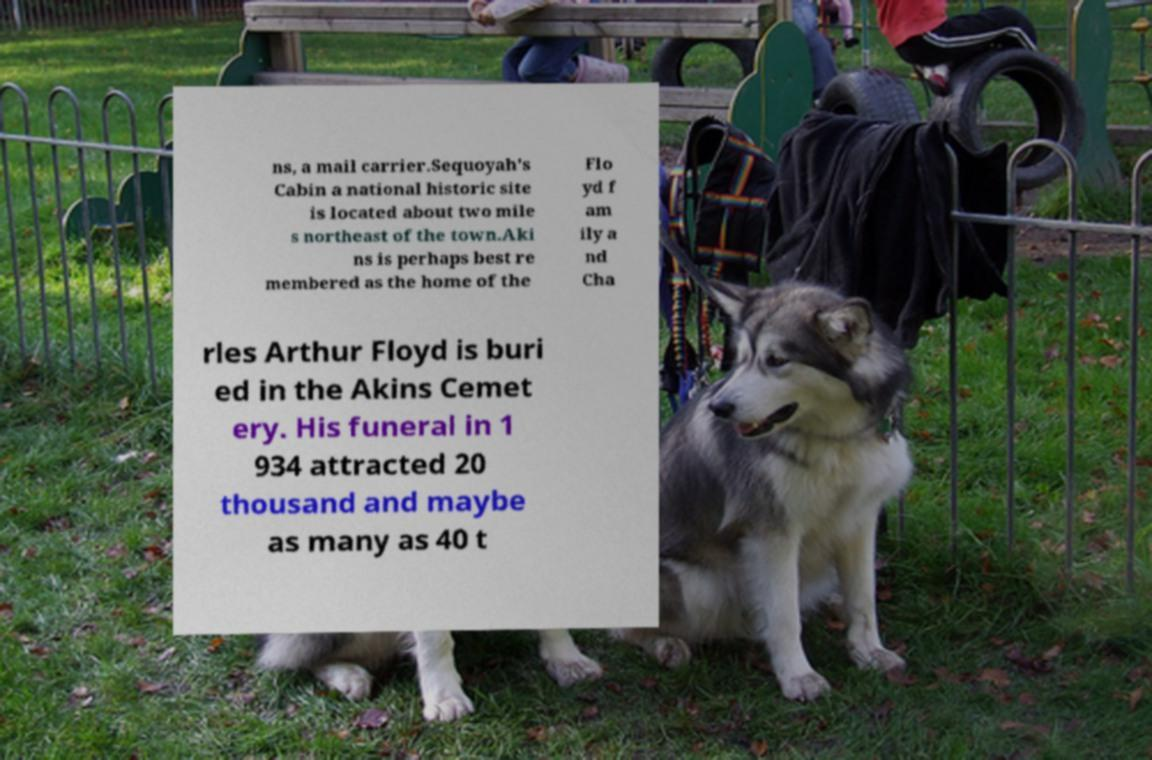I need the written content from this picture converted into text. Can you do that? ns, a mail carrier.Sequoyah's Cabin a national historic site is located about two mile s northeast of the town.Aki ns is perhaps best re membered as the home of the Flo yd f am ily a nd Cha rles Arthur Floyd is buri ed in the Akins Cemet ery. His funeral in 1 934 attracted 20 thousand and maybe as many as 40 t 